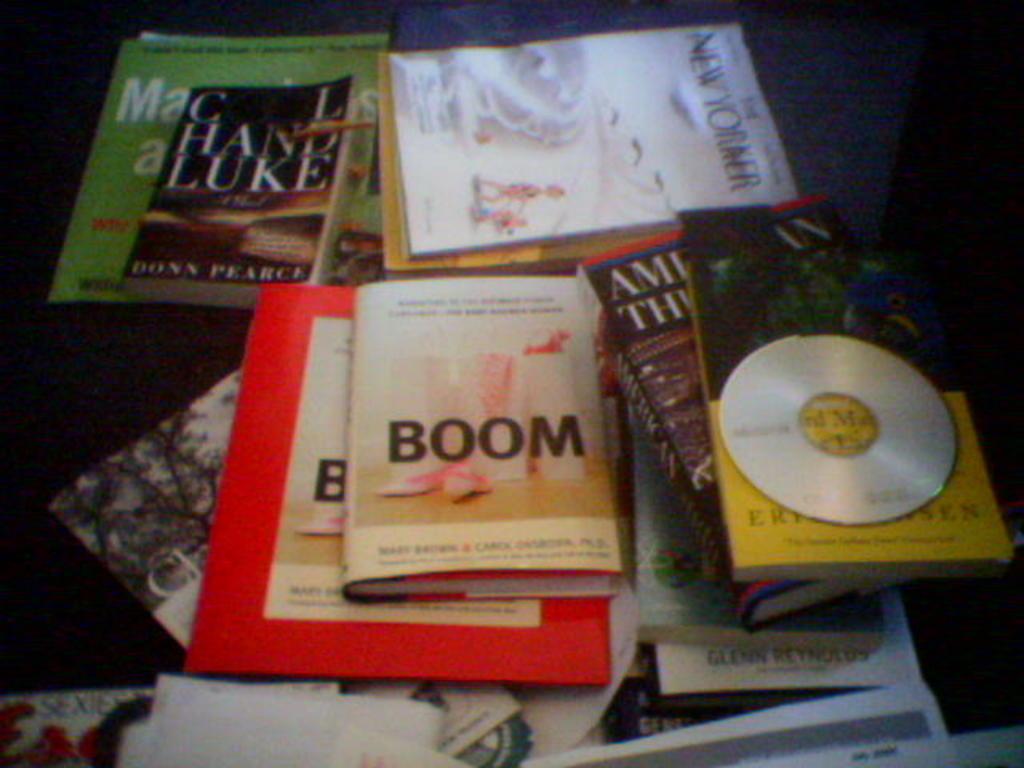What is the title of the middle book?
Your response must be concise. Boom. What is the title of the small book on the top?
Keep it short and to the point. Boom. 